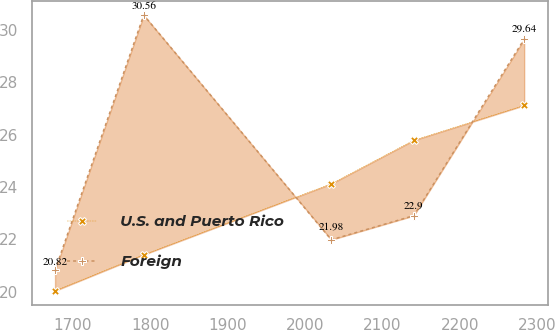Convert chart. <chart><loc_0><loc_0><loc_500><loc_500><line_chart><ecel><fcel>U.S. and Puerto Rico<fcel>Foreign<nl><fcel>1677.25<fcel>20.03<fcel>20.82<nl><fcel>1791.73<fcel>21.41<fcel>30.56<nl><fcel>2033.83<fcel>24.12<fcel>21.98<nl><fcel>2140.21<fcel>25.78<fcel>22.9<nl><fcel>2282.75<fcel>27.11<fcel>29.64<nl></chart> 